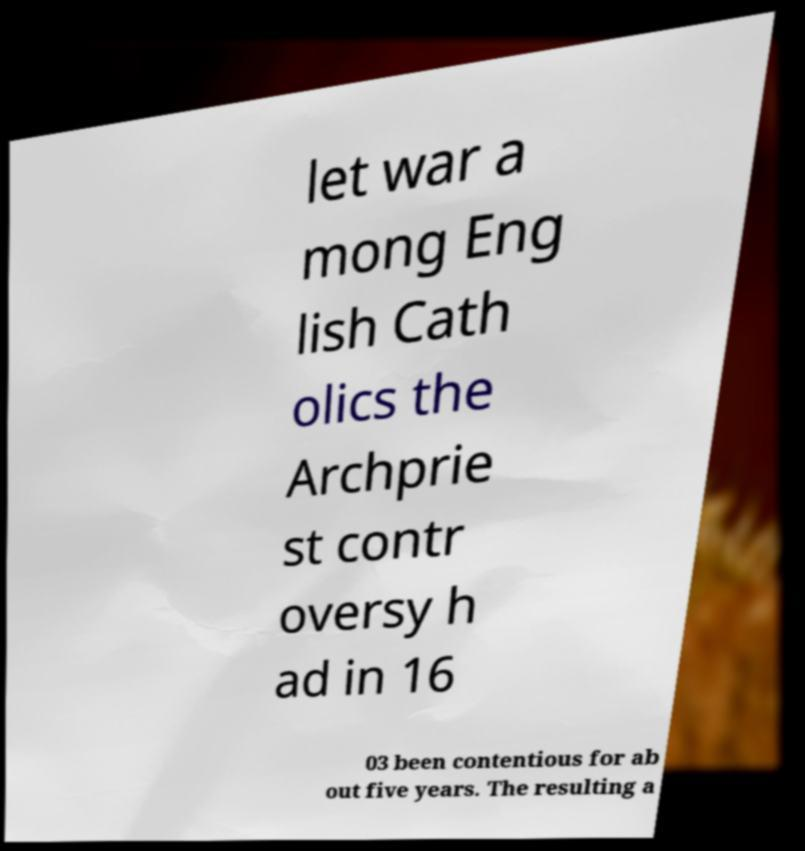There's text embedded in this image that I need extracted. Can you transcribe it verbatim? let war a mong Eng lish Cath olics the Archprie st contr oversy h ad in 16 03 been contentious for ab out five years. The resulting a 